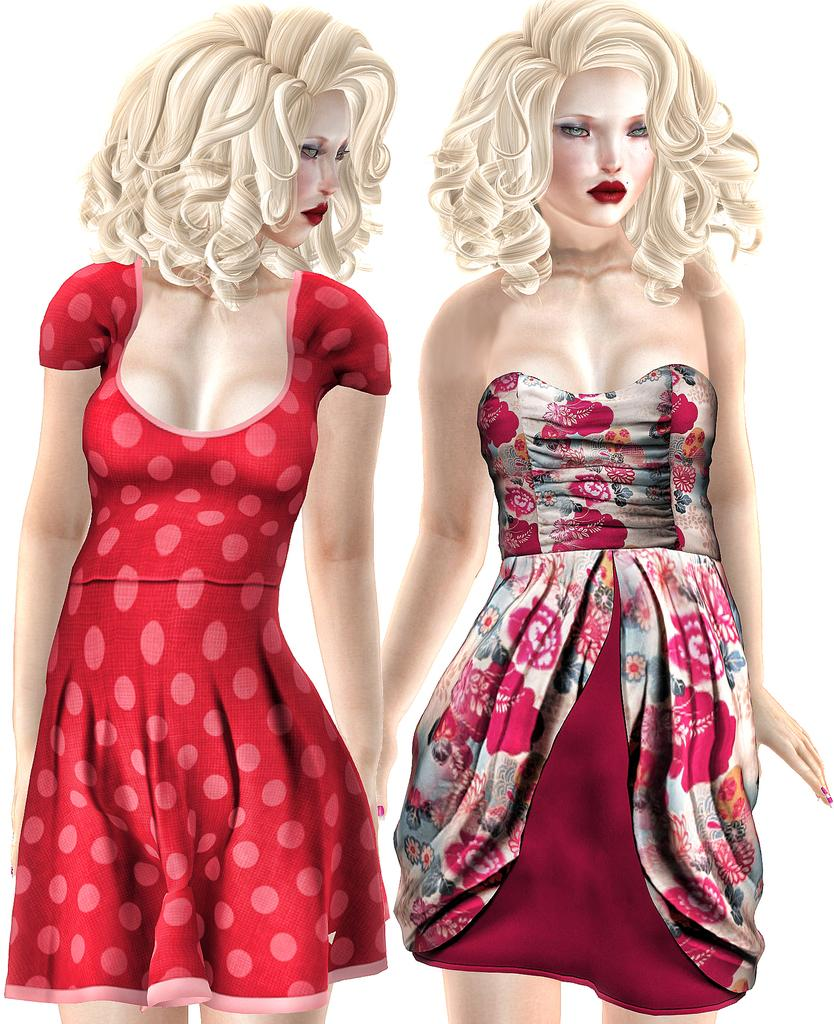What is the main subject of the image? There is a painting in the image. What is depicted in the painting? The painting depicts two women. Where are the women located within the painting? The women are in the middle of the painting. What type of loaf is being held by the father in the image? There is no father or loaf present in the image; it features a painting of two women. 